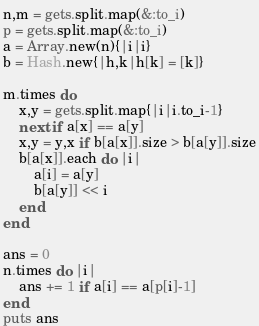Convert code to text. <code><loc_0><loc_0><loc_500><loc_500><_Ruby_>n,m = gets.split.map(&:to_i)
p = gets.split.map(&:to_i)
a = Array.new(n){|i|i}
b = Hash.new{|h,k|h[k] = [k]}

m.times do
    x,y = gets.split.map{|i|i.to_i-1}
    next if a[x] == a[y]
    x,y = y,x if b[a[x]].size > b[a[y]].size
    b[a[x]].each do |i|
        a[i] = a[y]
        b[a[y]] << i
    end
end

ans = 0
n.times do |i|
    ans += 1 if a[i] == a[p[i]-1]
end
puts ans</code> 